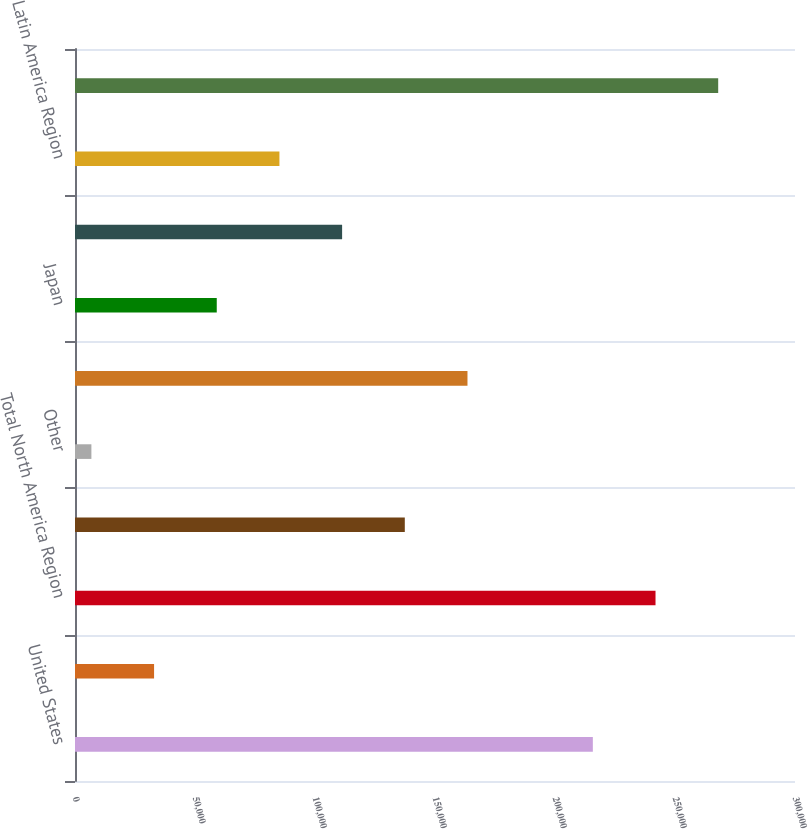Convert chart. <chart><loc_0><loc_0><loc_500><loc_500><bar_chart><fcel>United States<fcel>Canada<fcel>Total North America Region<fcel>Europe (b)<fcel>Other<fcel>Total EMEA Region<fcel>Japan<fcel>Total Asia Pacific Region<fcel>Latin America Region<fcel>Total Worldwide Retail Sales<nl><fcel>215766<fcel>32948.7<fcel>241882<fcel>137416<fcel>6832<fcel>163532<fcel>59065.4<fcel>111299<fcel>85182.1<fcel>267999<nl></chart> 